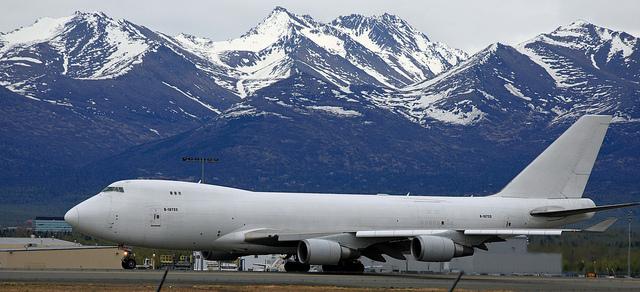Is it cold?
Concise answer only. Yes. What type of airplane is this?
Give a very brief answer. Jet. Is this an urban airport?
Keep it brief. No. 